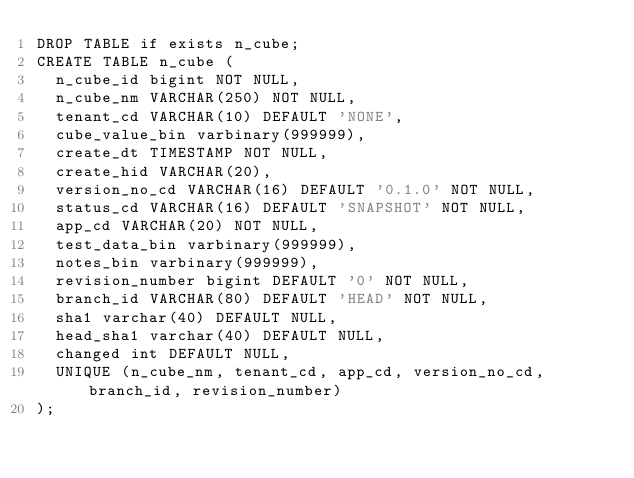Convert code to text. <code><loc_0><loc_0><loc_500><loc_500><_SQL_>DROP TABLE if exists n_cube;
CREATE TABLE n_cube (
  n_cube_id bigint NOT NULL,
  n_cube_nm VARCHAR(250) NOT NULL,
  tenant_cd VARCHAR(10) DEFAULT 'NONE',
  cube_value_bin varbinary(999999),
  create_dt TIMESTAMP NOT NULL,
  create_hid VARCHAR(20),
  version_no_cd VARCHAR(16) DEFAULT '0.1.0' NOT NULL,
  status_cd VARCHAR(16) DEFAULT 'SNAPSHOT' NOT NULL,
  app_cd VARCHAR(20) NOT NULL,
  test_data_bin varbinary(999999),
  notes_bin varbinary(999999),
  revision_number bigint DEFAULT '0' NOT NULL,
  branch_id VARCHAR(80) DEFAULT 'HEAD' NOT NULL,
  sha1 varchar(40) DEFAULT NULL,
  head_sha1 varchar(40) DEFAULT NULL,
  changed int DEFAULT NULL,
  UNIQUE (n_cube_nm, tenant_cd, app_cd, version_no_cd, branch_id, revision_number)
);</code> 